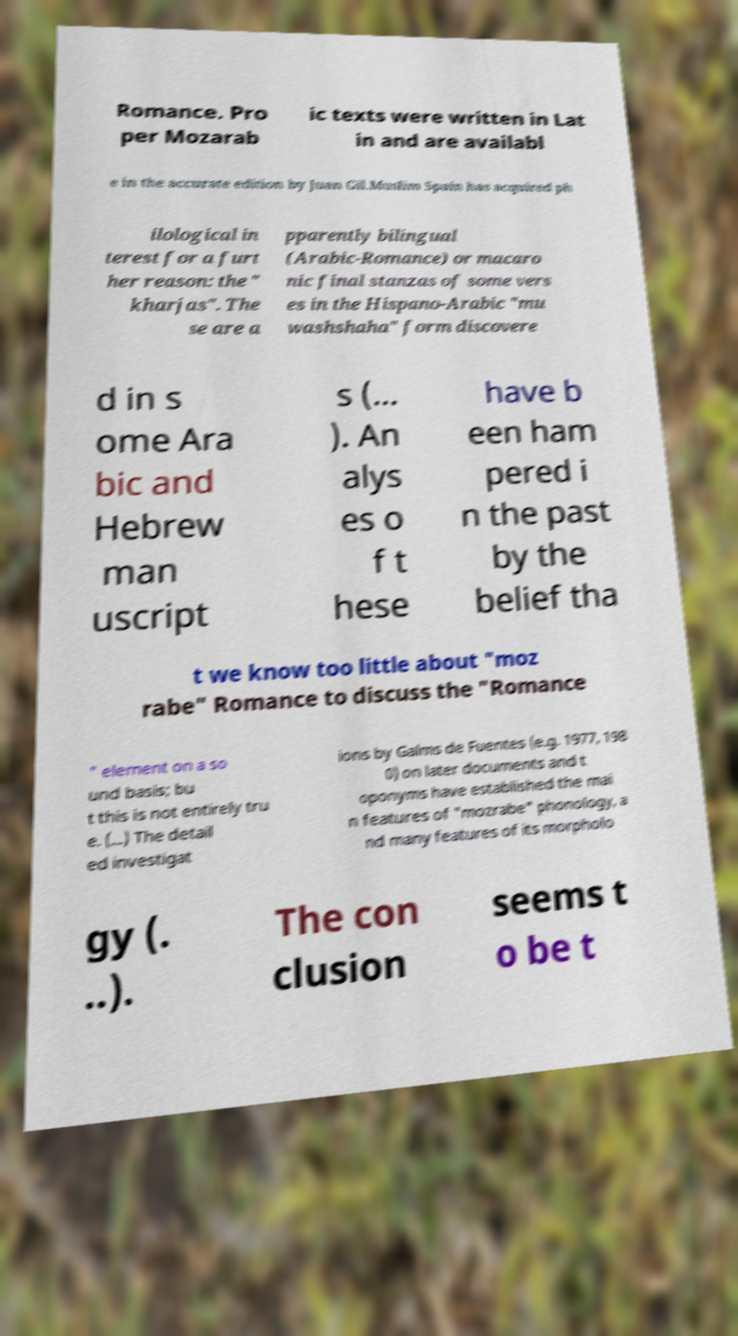For documentation purposes, I need the text within this image transcribed. Could you provide that? Romance. Pro per Mozarab ic texts were written in Lat in and are availabl e in the accurate edition by Juan Gil.Muslim Spain has acquired ph ilological in terest for a furt her reason: the " kharjas". The se are a pparently bilingual (Arabic-Romance) or macaro nic final stanzas of some vers es in the Hispano-Arabic "mu washshaha" form discovere d in s ome Ara bic and Hebrew man uscript s (... ). An alys es o f t hese have b een ham pered i n the past by the belief tha t we know too little about "moz rabe" Romance to discuss the "Romance " element on a so und basis; bu t this is not entirely tru e. (...) The detail ed investigat ions by Galms de Fuentes (e.g. 1977, 198 0) on later documents and t oponyms have established the mai n features of "mozrabe" phonology, a nd many features of its morpholo gy (. ..). The con clusion seems t o be t 